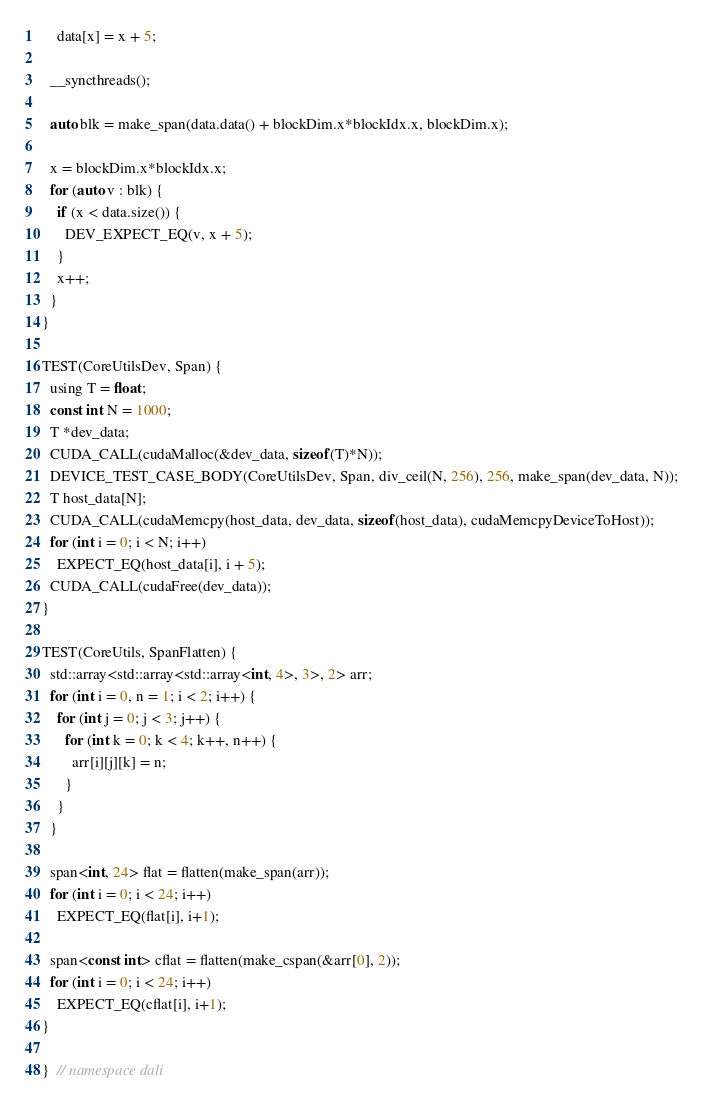<code> <loc_0><loc_0><loc_500><loc_500><_Cuda_>    data[x] = x + 5;

  __syncthreads();

  auto blk = make_span(data.data() + blockDim.x*blockIdx.x, blockDim.x);

  x = blockDim.x*blockIdx.x;
  for (auto v : blk) {
    if (x < data.size()) {
      DEV_EXPECT_EQ(v, x + 5);
    }
    x++;
  }
}

TEST(CoreUtilsDev, Span) {
  using T = float;
  const int N = 1000;
  T *dev_data;
  CUDA_CALL(cudaMalloc(&dev_data, sizeof(T)*N));
  DEVICE_TEST_CASE_BODY(CoreUtilsDev, Span, div_ceil(N, 256), 256, make_span(dev_data, N));
  T host_data[N];
  CUDA_CALL(cudaMemcpy(host_data, dev_data, sizeof(host_data), cudaMemcpyDeviceToHost));
  for (int i = 0; i < N; i++)
    EXPECT_EQ(host_data[i], i + 5);
  CUDA_CALL(cudaFree(dev_data));
}

TEST(CoreUtils, SpanFlatten) {
  std::array<std::array<std::array<int, 4>, 3>, 2> arr;
  for (int i = 0, n = 1; i < 2; i++) {
    for (int j = 0; j < 3; j++) {
      for (int k = 0; k < 4; k++, n++) {
        arr[i][j][k] = n;
      }
    }
  }

  span<int, 24> flat = flatten(make_span(arr));
  for (int i = 0; i < 24; i++)
    EXPECT_EQ(flat[i], i+1);

  span<const int> cflat = flatten(make_cspan(&arr[0], 2));
  for (int i = 0; i < 24; i++)
    EXPECT_EQ(cflat[i], i+1);
}

}  // namespace dali
</code> 